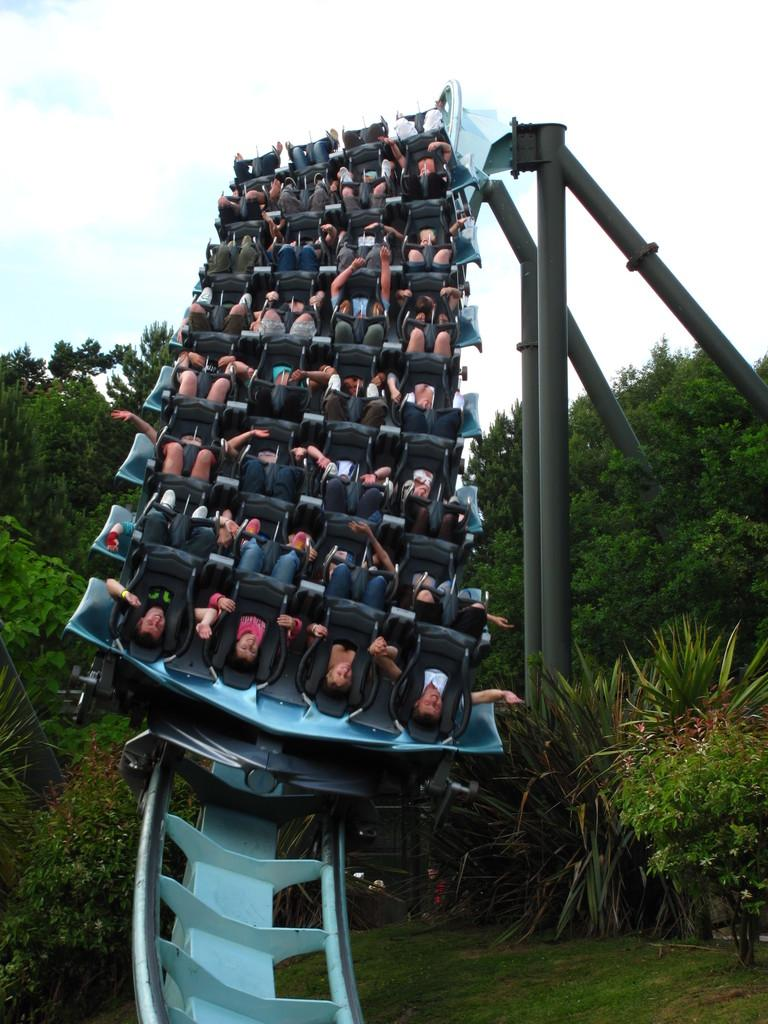What activity are the people in the image participating in? The people in the image are riding a roller coaster. What type of structure can be seen in the image? There are poles visible in the image, which are part of the roller coaster. What type of vegetation is present in the image? Trees, grass, and plants are present in the image. What is visible in the background of the image? The sky is visible in the background of the image. What can be seen in the sky? Clouds are present in the sky. What type of polish is being applied to the roller coaster in the image? There is no polish being applied to the roller coaster in the image; it is a ride for people to enjoy. What color of paint is used on the trees in the image? The trees in the image are not painted, and therefore no specific color of paint can be determined. 